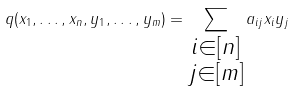<formula> <loc_0><loc_0><loc_500><loc_500>q ( x _ { 1 } , \dots , x _ { n } , y _ { 1 } , \dots , y _ { m } ) = \sum _ { \substack { i \in [ n ] \\ j \in [ m ] } } a _ { i j } x _ { i } y _ { j }</formula> 